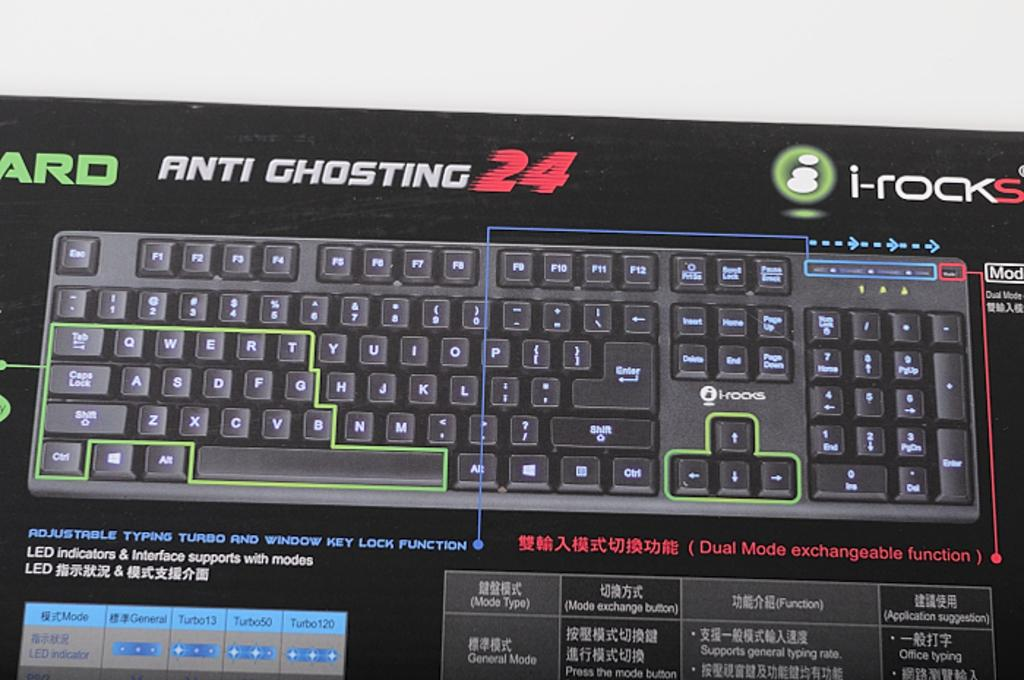<image>
Give a short and clear explanation of the subsequent image. A box for a keyboard with anti ghosting 24 ability from i-rocks 